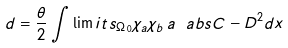<formula> <loc_0><loc_0><loc_500><loc_500>d = { \frac { \theta } { 2 } } \int \lim i t s _ { \Omega _ { 0 } } \chi _ { a } \chi _ { b } \, a \ a b s { C - D } ^ { 2 } d x</formula> 